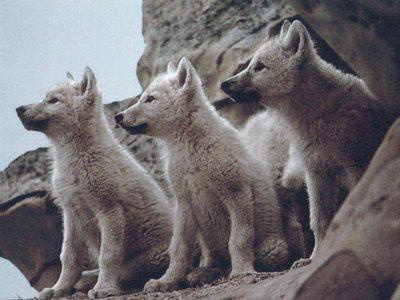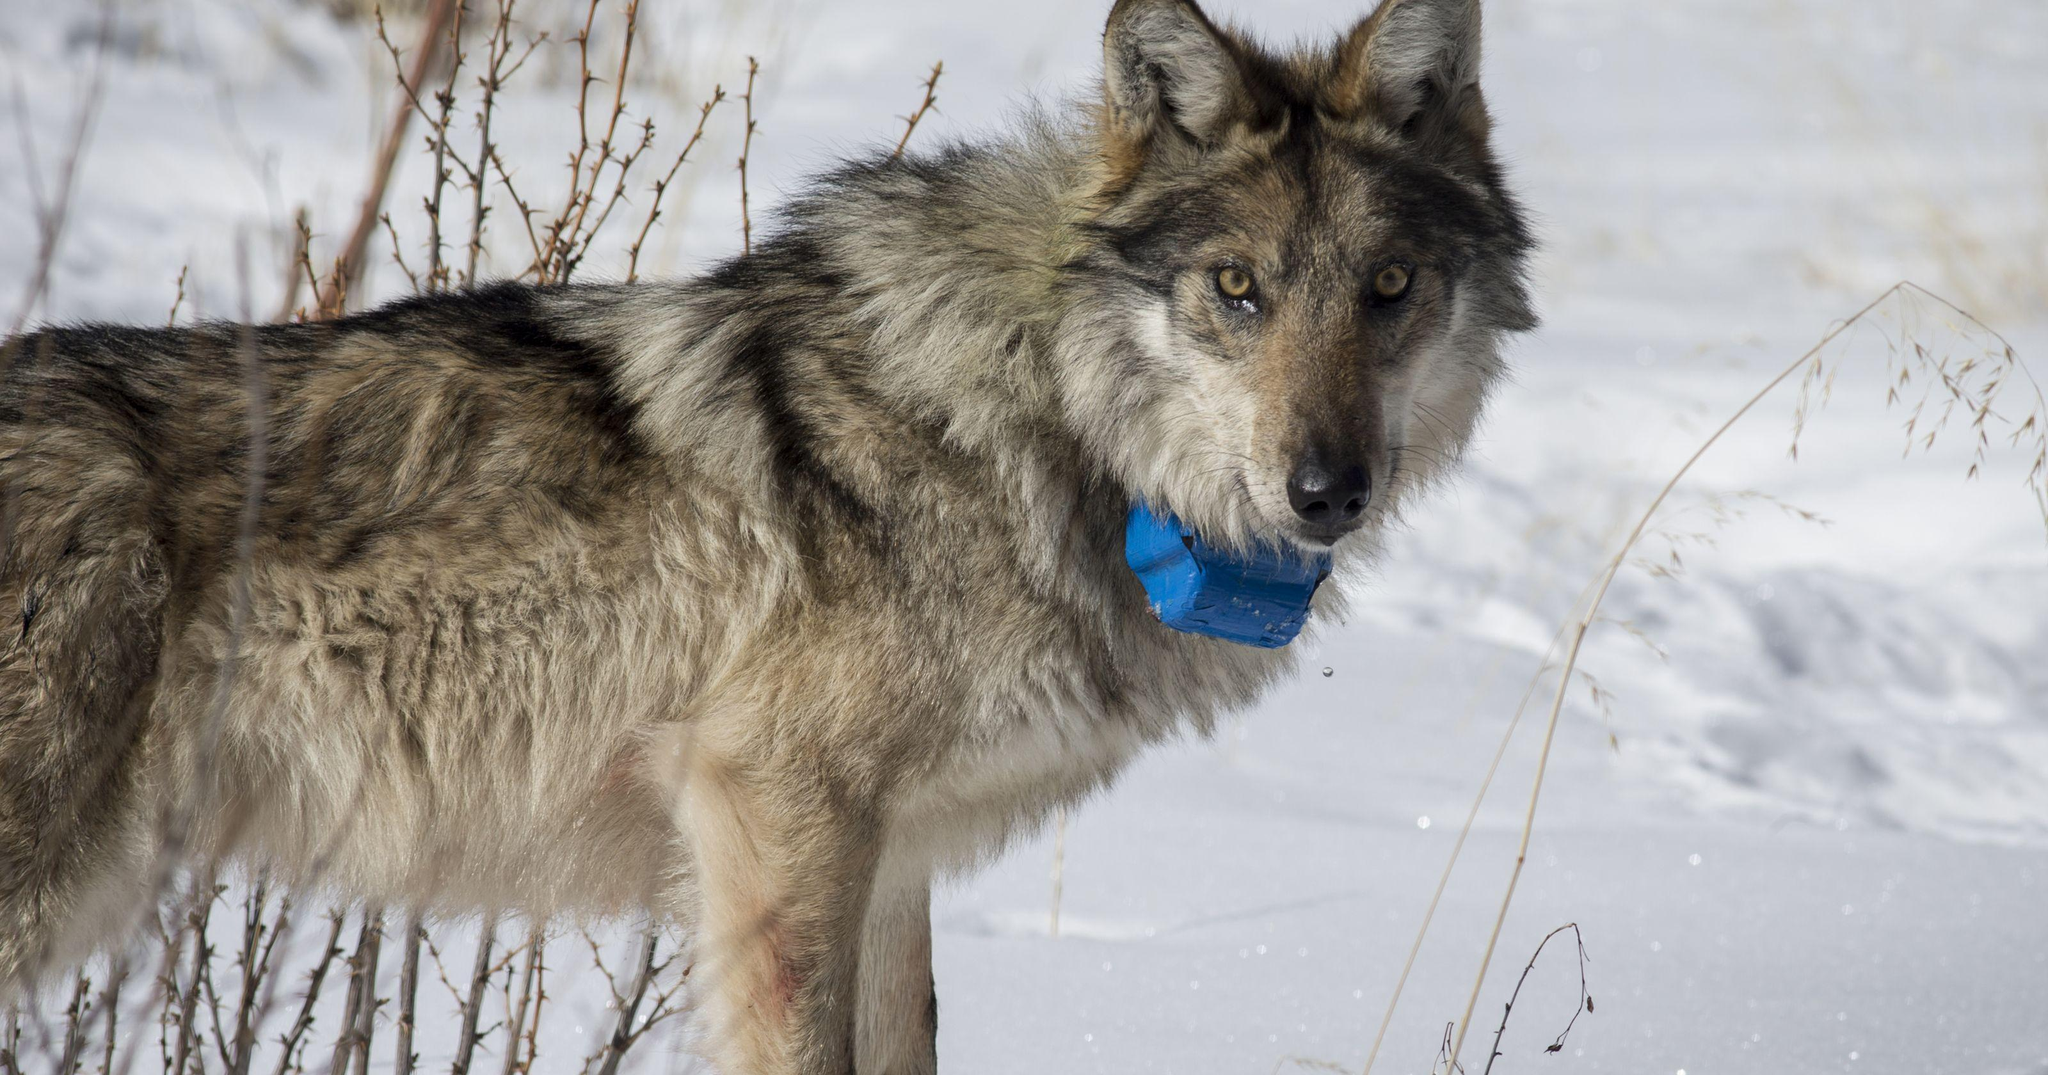The first image is the image on the left, the second image is the image on the right. Examine the images to the left and right. Is the description "There are exactly two wolves in total." accurate? Answer yes or no. No. The first image is the image on the left, the second image is the image on the right. For the images displayed, is the sentence "The left image contains at least two wolves." factually correct? Answer yes or no. Yes. 